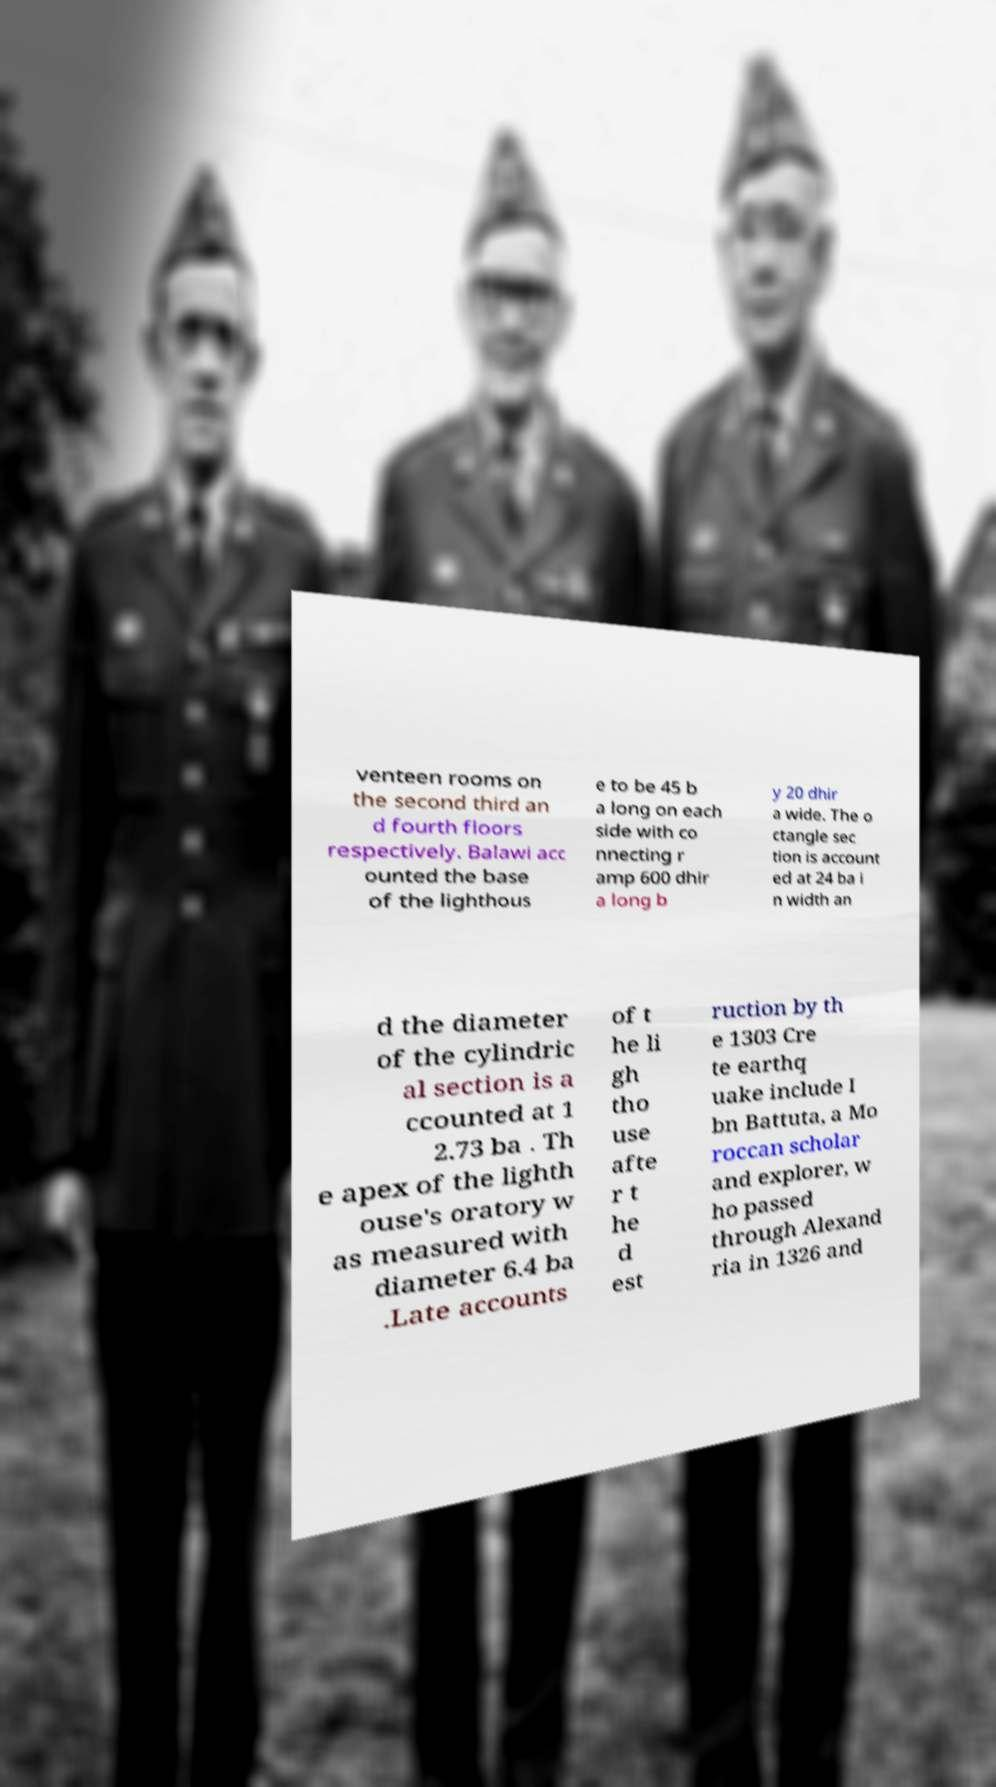Please identify and transcribe the text found in this image. venteen rooms on the second third an d fourth floors respectively. Balawi acc ounted the base of the lighthous e to be 45 b a long on each side with co nnecting r amp 600 dhir a long b y 20 dhir a wide. The o ctangle sec tion is account ed at 24 ba i n width an d the diameter of the cylindric al section is a ccounted at 1 2.73 ba . Th e apex of the lighth ouse's oratory w as measured with diameter 6.4 ba .Late accounts of t he li gh tho use afte r t he d est ruction by th e 1303 Cre te earthq uake include I bn Battuta, a Mo roccan scholar and explorer, w ho passed through Alexand ria in 1326 and 